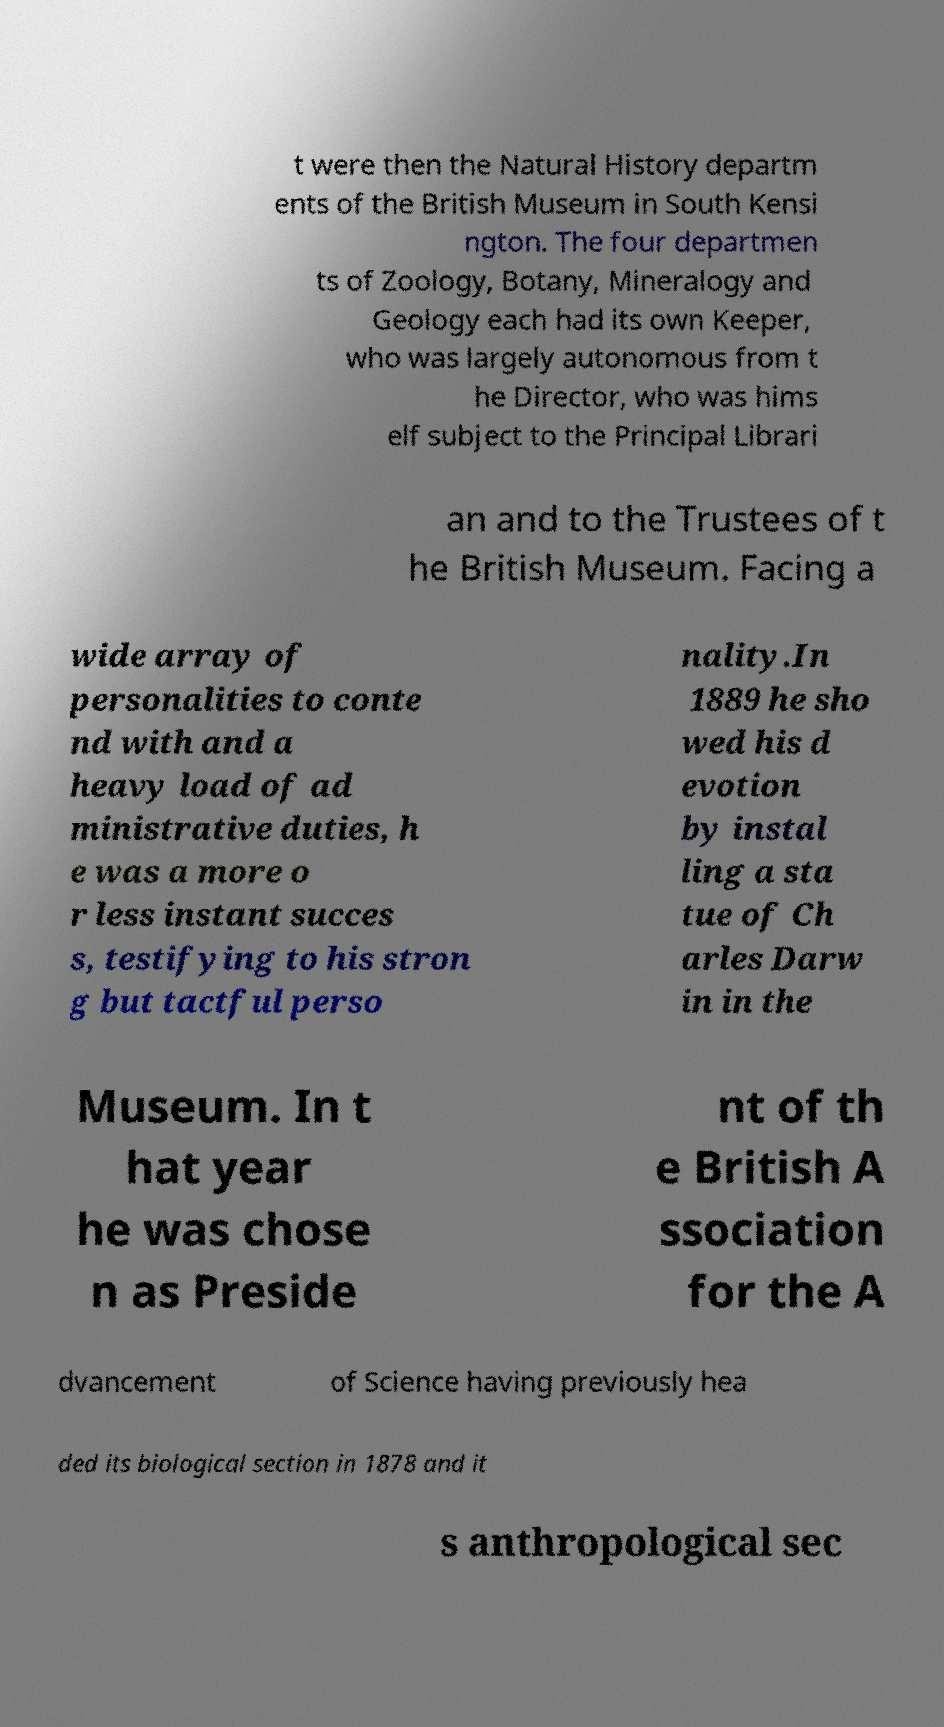Could you assist in decoding the text presented in this image and type it out clearly? t were then the Natural History departm ents of the British Museum in South Kensi ngton. The four departmen ts of Zoology, Botany, Mineralogy and Geology each had its own Keeper, who was largely autonomous from t he Director, who was hims elf subject to the Principal Librari an and to the Trustees of t he British Museum. Facing a wide array of personalities to conte nd with and a heavy load of ad ministrative duties, h e was a more o r less instant succes s, testifying to his stron g but tactful perso nality.In 1889 he sho wed his d evotion by instal ling a sta tue of Ch arles Darw in in the Museum. In t hat year he was chose n as Preside nt of th e British A ssociation for the A dvancement of Science having previously hea ded its biological section in 1878 and it s anthropological sec 